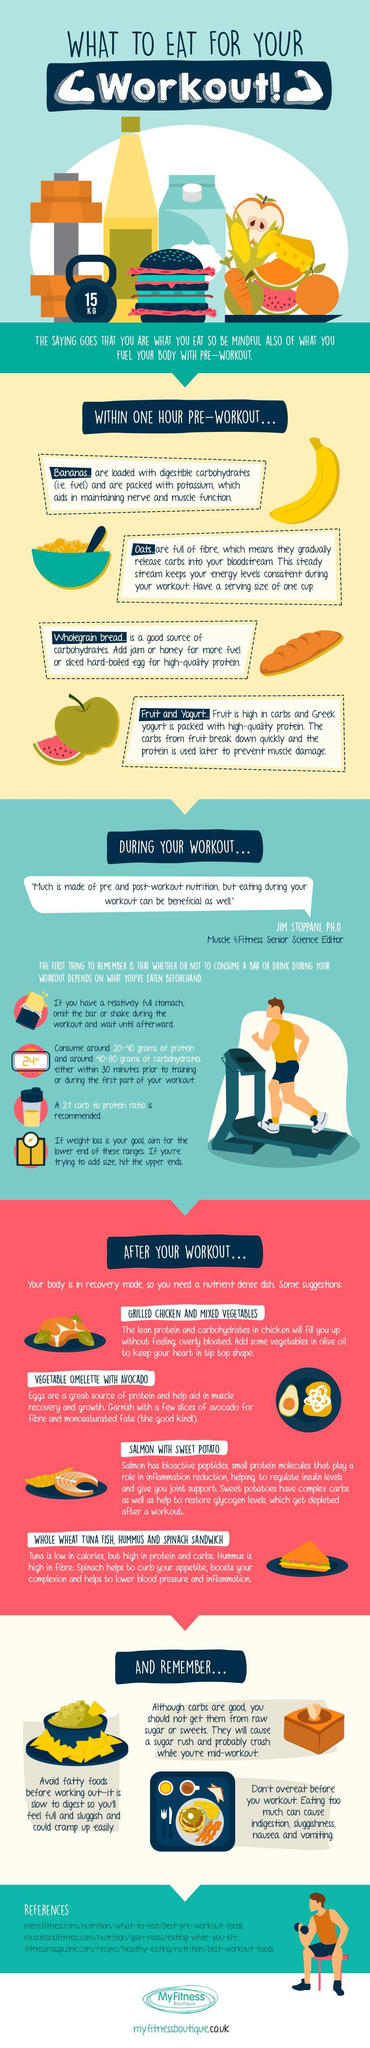Draw attention to some important aspects in this diagram. Three references are cited in total. The weight of the kettlebell is 15 kilograms. 